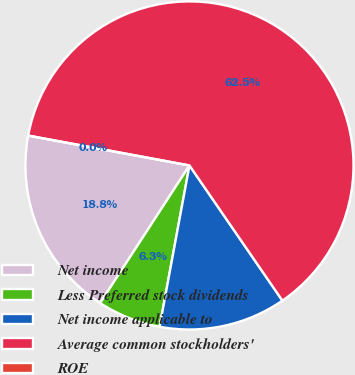<chart> <loc_0><loc_0><loc_500><loc_500><pie_chart><fcel>Net income<fcel>Less Preferred stock dividends<fcel>Net income applicable to<fcel>Average common stockholders'<fcel>ROE<nl><fcel>18.75%<fcel>6.25%<fcel>12.5%<fcel>62.49%<fcel>0.0%<nl></chart> 